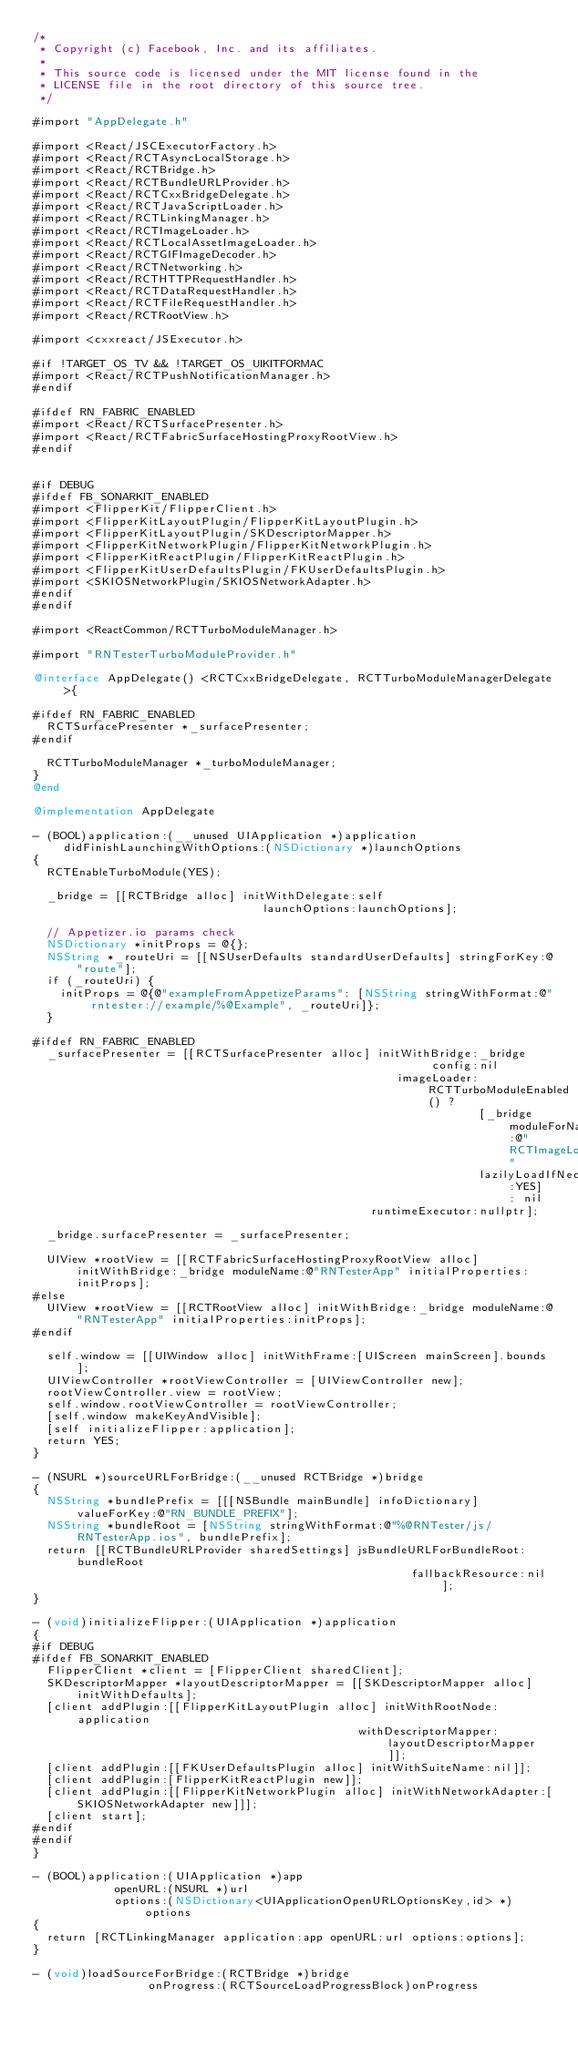Convert code to text. <code><loc_0><loc_0><loc_500><loc_500><_ObjectiveC_>/*
 * Copyright (c) Facebook, Inc. and its affiliates.
 *
 * This source code is licensed under the MIT license found in the
 * LICENSE file in the root directory of this source tree.
 */

#import "AppDelegate.h"

#import <React/JSCExecutorFactory.h>
#import <React/RCTAsyncLocalStorage.h>
#import <React/RCTBridge.h>
#import <React/RCTBundleURLProvider.h>
#import <React/RCTCxxBridgeDelegate.h>
#import <React/RCTJavaScriptLoader.h>
#import <React/RCTLinkingManager.h>
#import <React/RCTImageLoader.h>
#import <React/RCTLocalAssetImageLoader.h>
#import <React/RCTGIFImageDecoder.h>
#import <React/RCTNetworking.h>
#import <React/RCTHTTPRequestHandler.h>
#import <React/RCTDataRequestHandler.h>
#import <React/RCTFileRequestHandler.h>
#import <React/RCTRootView.h>

#import <cxxreact/JSExecutor.h>

#if !TARGET_OS_TV && !TARGET_OS_UIKITFORMAC
#import <React/RCTPushNotificationManager.h>
#endif

#ifdef RN_FABRIC_ENABLED
#import <React/RCTSurfacePresenter.h>
#import <React/RCTFabricSurfaceHostingProxyRootView.h>
#endif

  
#if DEBUG
#ifdef FB_SONARKIT_ENABLED
#import <FlipperKit/FlipperClient.h>
#import <FlipperKitLayoutPlugin/FlipperKitLayoutPlugin.h>
#import <FlipperKitLayoutPlugin/SKDescriptorMapper.h>
#import <FlipperKitNetworkPlugin/FlipperKitNetworkPlugin.h>
#import <FlipperKitReactPlugin/FlipperKitReactPlugin.h>
#import <FlipperKitUserDefaultsPlugin/FKUserDefaultsPlugin.h>
#import <SKIOSNetworkPlugin/SKIOSNetworkAdapter.h>
#endif
#endif

#import <ReactCommon/RCTTurboModuleManager.h>

#import "RNTesterTurboModuleProvider.h"

@interface AppDelegate() <RCTCxxBridgeDelegate, RCTTurboModuleManagerDelegate>{

#ifdef RN_FABRIC_ENABLED
  RCTSurfacePresenter *_surfacePresenter;
#endif

  RCTTurboModuleManager *_turboModuleManager;
}
@end

@implementation AppDelegate

- (BOOL)application:(__unused UIApplication *)application didFinishLaunchingWithOptions:(NSDictionary *)launchOptions
{
  RCTEnableTurboModule(YES);

  _bridge = [[RCTBridge alloc] initWithDelegate:self
                                  launchOptions:launchOptions];

  // Appetizer.io params check
  NSDictionary *initProps = @{};
  NSString *_routeUri = [[NSUserDefaults standardUserDefaults] stringForKey:@"route"];
  if (_routeUri) {
    initProps = @{@"exampleFromAppetizeParams": [NSString stringWithFormat:@"rntester://example/%@Example", _routeUri]};
  }

#ifdef RN_FABRIC_ENABLED
  _surfacePresenter = [[RCTSurfacePresenter alloc] initWithBridge:_bridge
                                                           config:nil
                                                      imageLoader:RCTTurboModuleEnabled() ?
                                                                  [_bridge moduleForName:@"RCTImageLoader"
                                                                  lazilyLoadIfNecessary:YES] : nil
                                                  runtimeExecutor:nullptr];

  _bridge.surfacePresenter = _surfacePresenter;

  UIView *rootView = [[RCTFabricSurfaceHostingProxyRootView alloc] initWithBridge:_bridge moduleName:@"RNTesterApp" initialProperties:initProps];
#else
  UIView *rootView = [[RCTRootView alloc] initWithBridge:_bridge moduleName:@"RNTesterApp" initialProperties:initProps];
#endif

  self.window = [[UIWindow alloc] initWithFrame:[UIScreen mainScreen].bounds];
  UIViewController *rootViewController = [UIViewController new];
  rootViewController.view = rootView;
  self.window.rootViewController = rootViewController;
  [self.window makeKeyAndVisible];
  [self initializeFlipper:application];
  return YES;
}

- (NSURL *)sourceURLForBridge:(__unused RCTBridge *)bridge
{
  NSString *bundlePrefix = [[[NSBundle mainBundle] infoDictionary] valueForKey:@"RN_BUNDLE_PREFIX"];
  NSString *bundleRoot = [NSString stringWithFormat:@"%@RNTester/js/RNTesterApp.ios", bundlePrefix];
  return [[RCTBundleURLProvider sharedSettings] jsBundleURLForBundleRoot:bundleRoot
                                                        fallbackResource:nil];
}

- (void)initializeFlipper:(UIApplication *)application
{
#if DEBUG
#ifdef FB_SONARKIT_ENABLED
  FlipperClient *client = [FlipperClient sharedClient];
  SKDescriptorMapper *layoutDescriptorMapper = [[SKDescriptorMapper alloc] initWithDefaults];
  [client addPlugin:[[FlipperKitLayoutPlugin alloc] initWithRootNode:application
                                                withDescriptorMapper:layoutDescriptorMapper]];
  [client addPlugin:[[FKUserDefaultsPlugin alloc] initWithSuiteName:nil]];
  [client addPlugin:[FlipperKitReactPlugin new]];
  [client addPlugin:[[FlipperKitNetworkPlugin alloc] initWithNetworkAdapter:[SKIOSNetworkAdapter new]]];
  [client start];
#endif
#endif
}

- (BOOL)application:(UIApplication *)app
            openURL:(NSURL *)url
            options:(NSDictionary<UIApplicationOpenURLOptionsKey,id> *)options
{
  return [RCTLinkingManager application:app openURL:url options:options];
}

- (void)loadSourceForBridge:(RCTBridge *)bridge
                 onProgress:(RCTSourceLoadProgressBlock)onProgress</code> 